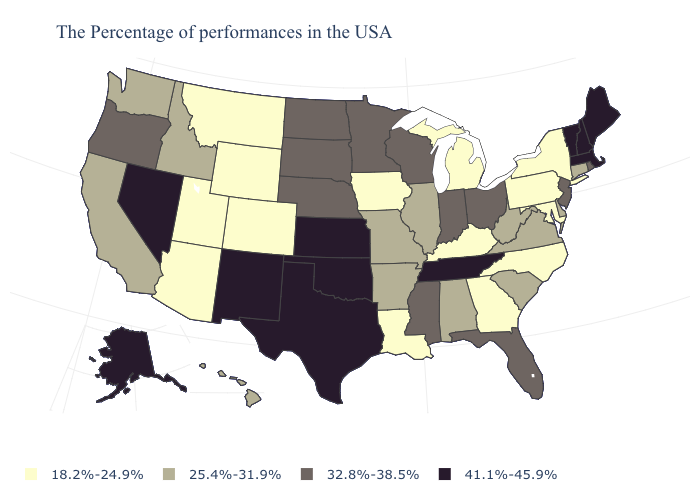Among the states that border Connecticut , which have the highest value?
Concise answer only. Massachusetts. What is the value of Michigan?
Give a very brief answer. 18.2%-24.9%. Among the states that border Washington , does Oregon have the highest value?
Be succinct. Yes. Does the map have missing data?
Concise answer only. No. Name the states that have a value in the range 32.8%-38.5%?
Write a very short answer. Rhode Island, New Jersey, Ohio, Florida, Indiana, Wisconsin, Mississippi, Minnesota, Nebraska, South Dakota, North Dakota, Oregon. Which states have the highest value in the USA?
Concise answer only. Maine, Massachusetts, New Hampshire, Vermont, Tennessee, Kansas, Oklahoma, Texas, New Mexico, Nevada, Alaska. Which states have the highest value in the USA?
Short answer required. Maine, Massachusetts, New Hampshire, Vermont, Tennessee, Kansas, Oklahoma, Texas, New Mexico, Nevada, Alaska. How many symbols are there in the legend?
Write a very short answer. 4. Does Alaska have the lowest value in the USA?
Answer briefly. No. Name the states that have a value in the range 25.4%-31.9%?
Be succinct. Connecticut, Delaware, Virginia, South Carolina, West Virginia, Alabama, Illinois, Missouri, Arkansas, Idaho, California, Washington, Hawaii. Name the states that have a value in the range 32.8%-38.5%?
Keep it brief. Rhode Island, New Jersey, Ohio, Florida, Indiana, Wisconsin, Mississippi, Minnesota, Nebraska, South Dakota, North Dakota, Oregon. Name the states that have a value in the range 18.2%-24.9%?
Quick response, please. New York, Maryland, Pennsylvania, North Carolina, Georgia, Michigan, Kentucky, Louisiana, Iowa, Wyoming, Colorado, Utah, Montana, Arizona. Among the states that border New Jersey , which have the highest value?
Quick response, please. Delaware. Among the states that border Wyoming , which have the lowest value?
Be succinct. Colorado, Utah, Montana. Among the states that border Connecticut , does Massachusetts have the lowest value?
Keep it brief. No. 